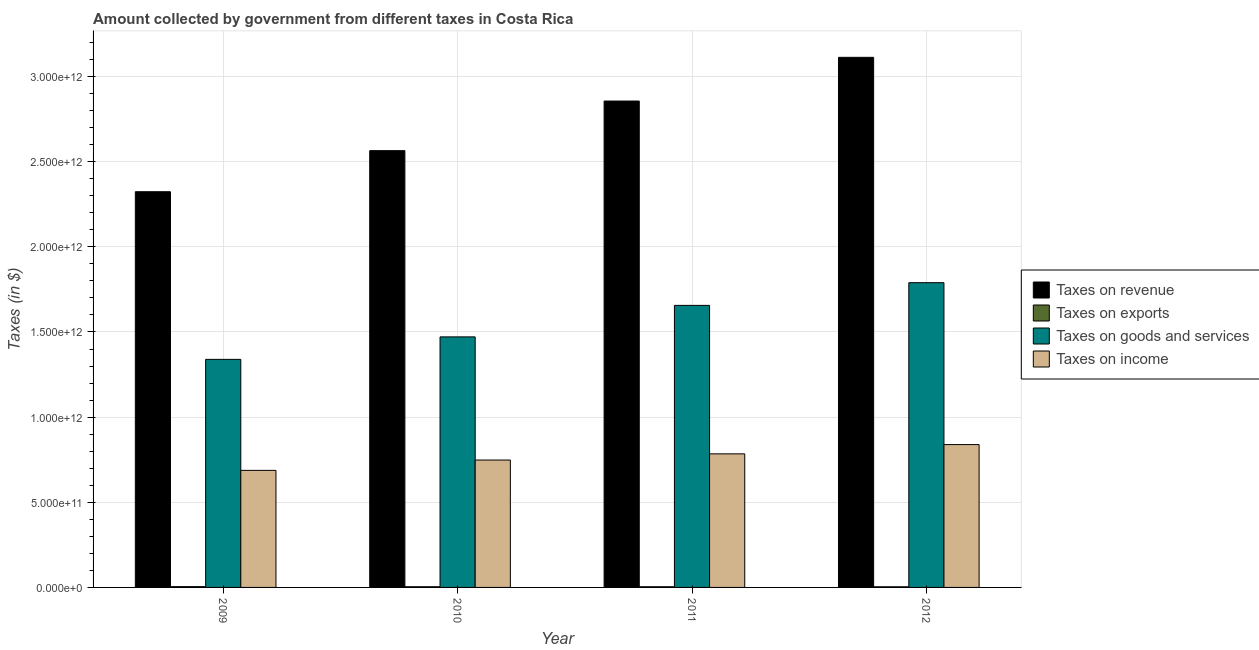What is the amount collected as tax on exports in 2010?
Make the answer very short. 3.97e+09. Across all years, what is the maximum amount collected as tax on exports?
Your response must be concise. 4.68e+09. Across all years, what is the minimum amount collected as tax on exports?
Your answer should be compact. 3.82e+09. In which year was the amount collected as tax on goods maximum?
Your answer should be compact. 2012. In which year was the amount collected as tax on exports minimum?
Offer a very short reply. 2012. What is the total amount collected as tax on exports in the graph?
Offer a terse response. 1.65e+1. What is the difference between the amount collected as tax on income in 2010 and that in 2011?
Give a very brief answer. -3.63e+1. What is the difference between the amount collected as tax on revenue in 2009 and the amount collected as tax on goods in 2011?
Give a very brief answer. -5.33e+11. What is the average amount collected as tax on goods per year?
Your answer should be compact. 1.56e+12. What is the ratio of the amount collected as tax on revenue in 2009 to that in 2011?
Keep it short and to the point. 0.81. Is the amount collected as tax on revenue in 2009 less than that in 2011?
Provide a short and direct response. Yes. What is the difference between the highest and the second highest amount collected as tax on income?
Provide a short and direct response. 5.44e+1. What is the difference between the highest and the lowest amount collected as tax on revenue?
Make the answer very short. 7.89e+11. What does the 1st bar from the left in 2009 represents?
Offer a terse response. Taxes on revenue. What does the 4th bar from the right in 2011 represents?
Your answer should be very brief. Taxes on revenue. Is it the case that in every year, the sum of the amount collected as tax on revenue and amount collected as tax on exports is greater than the amount collected as tax on goods?
Offer a terse response. Yes. How many bars are there?
Offer a very short reply. 16. Are all the bars in the graph horizontal?
Your answer should be very brief. No. What is the difference between two consecutive major ticks on the Y-axis?
Your answer should be compact. 5.00e+11. Are the values on the major ticks of Y-axis written in scientific E-notation?
Provide a short and direct response. Yes. Does the graph contain any zero values?
Offer a very short reply. No. Does the graph contain grids?
Offer a very short reply. Yes. Where does the legend appear in the graph?
Make the answer very short. Center right. How are the legend labels stacked?
Your answer should be very brief. Vertical. What is the title of the graph?
Your answer should be compact. Amount collected by government from different taxes in Costa Rica. Does "UNDP" appear as one of the legend labels in the graph?
Offer a terse response. No. What is the label or title of the Y-axis?
Make the answer very short. Taxes (in $). What is the Taxes (in $) of Taxes on revenue in 2009?
Give a very brief answer. 2.32e+12. What is the Taxes (in $) in Taxes on exports in 2009?
Make the answer very short. 4.68e+09. What is the Taxes (in $) in Taxes on goods and services in 2009?
Your answer should be compact. 1.34e+12. What is the Taxes (in $) in Taxes on income in 2009?
Offer a terse response. 6.87e+11. What is the Taxes (in $) of Taxes on revenue in 2010?
Provide a succinct answer. 2.56e+12. What is the Taxes (in $) in Taxes on exports in 2010?
Ensure brevity in your answer.  3.97e+09. What is the Taxes (in $) of Taxes on goods and services in 2010?
Your response must be concise. 1.47e+12. What is the Taxes (in $) in Taxes on income in 2010?
Make the answer very short. 7.48e+11. What is the Taxes (in $) in Taxes on revenue in 2011?
Make the answer very short. 2.86e+12. What is the Taxes (in $) in Taxes on exports in 2011?
Ensure brevity in your answer.  3.99e+09. What is the Taxes (in $) of Taxes on goods and services in 2011?
Ensure brevity in your answer.  1.66e+12. What is the Taxes (in $) of Taxes on income in 2011?
Provide a succinct answer. 7.84e+11. What is the Taxes (in $) in Taxes on revenue in 2012?
Your answer should be compact. 3.11e+12. What is the Taxes (in $) of Taxes on exports in 2012?
Provide a succinct answer. 3.82e+09. What is the Taxes (in $) in Taxes on goods and services in 2012?
Your answer should be compact. 1.79e+12. What is the Taxes (in $) in Taxes on income in 2012?
Offer a terse response. 8.39e+11. Across all years, what is the maximum Taxes (in $) in Taxes on revenue?
Ensure brevity in your answer.  3.11e+12. Across all years, what is the maximum Taxes (in $) in Taxes on exports?
Ensure brevity in your answer.  4.68e+09. Across all years, what is the maximum Taxes (in $) in Taxes on goods and services?
Make the answer very short. 1.79e+12. Across all years, what is the maximum Taxes (in $) in Taxes on income?
Provide a short and direct response. 8.39e+11. Across all years, what is the minimum Taxes (in $) in Taxes on revenue?
Give a very brief answer. 2.32e+12. Across all years, what is the minimum Taxes (in $) in Taxes on exports?
Offer a terse response. 3.82e+09. Across all years, what is the minimum Taxes (in $) in Taxes on goods and services?
Provide a short and direct response. 1.34e+12. Across all years, what is the minimum Taxes (in $) in Taxes on income?
Your answer should be very brief. 6.87e+11. What is the total Taxes (in $) in Taxes on revenue in the graph?
Keep it short and to the point. 1.09e+13. What is the total Taxes (in $) in Taxes on exports in the graph?
Your answer should be compact. 1.65e+1. What is the total Taxes (in $) of Taxes on goods and services in the graph?
Ensure brevity in your answer.  6.26e+12. What is the total Taxes (in $) in Taxes on income in the graph?
Give a very brief answer. 3.06e+12. What is the difference between the Taxes (in $) in Taxes on revenue in 2009 and that in 2010?
Your response must be concise. -2.41e+11. What is the difference between the Taxes (in $) in Taxes on exports in 2009 and that in 2010?
Offer a terse response. 7.04e+08. What is the difference between the Taxes (in $) in Taxes on goods and services in 2009 and that in 2010?
Your answer should be very brief. -1.32e+11. What is the difference between the Taxes (in $) in Taxes on income in 2009 and that in 2010?
Make the answer very short. -6.07e+1. What is the difference between the Taxes (in $) in Taxes on revenue in 2009 and that in 2011?
Make the answer very short. -5.33e+11. What is the difference between the Taxes (in $) in Taxes on exports in 2009 and that in 2011?
Make the answer very short. 6.87e+08. What is the difference between the Taxes (in $) in Taxes on goods and services in 2009 and that in 2011?
Provide a succinct answer. -3.17e+11. What is the difference between the Taxes (in $) of Taxes on income in 2009 and that in 2011?
Offer a very short reply. -9.70e+1. What is the difference between the Taxes (in $) in Taxes on revenue in 2009 and that in 2012?
Your answer should be compact. -7.89e+11. What is the difference between the Taxes (in $) of Taxes on exports in 2009 and that in 2012?
Give a very brief answer. 8.54e+08. What is the difference between the Taxes (in $) in Taxes on goods and services in 2009 and that in 2012?
Make the answer very short. -4.50e+11. What is the difference between the Taxes (in $) of Taxes on income in 2009 and that in 2012?
Make the answer very short. -1.51e+11. What is the difference between the Taxes (in $) of Taxes on revenue in 2010 and that in 2011?
Provide a short and direct response. -2.91e+11. What is the difference between the Taxes (in $) of Taxes on exports in 2010 and that in 2011?
Your answer should be very brief. -1.76e+07. What is the difference between the Taxes (in $) in Taxes on goods and services in 2010 and that in 2011?
Ensure brevity in your answer.  -1.85e+11. What is the difference between the Taxes (in $) in Taxes on income in 2010 and that in 2011?
Your answer should be compact. -3.63e+1. What is the difference between the Taxes (in $) in Taxes on revenue in 2010 and that in 2012?
Keep it short and to the point. -5.48e+11. What is the difference between the Taxes (in $) of Taxes on exports in 2010 and that in 2012?
Your answer should be very brief. 1.49e+08. What is the difference between the Taxes (in $) in Taxes on goods and services in 2010 and that in 2012?
Keep it short and to the point. -3.18e+11. What is the difference between the Taxes (in $) in Taxes on income in 2010 and that in 2012?
Your answer should be compact. -9.07e+1. What is the difference between the Taxes (in $) in Taxes on revenue in 2011 and that in 2012?
Keep it short and to the point. -2.57e+11. What is the difference between the Taxes (in $) of Taxes on exports in 2011 and that in 2012?
Your answer should be very brief. 1.67e+08. What is the difference between the Taxes (in $) in Taxes on goods and services in 2011 and that in 2012?
Provide a succinct answer. -1.33e+11. What is the difference between the Taxes (in $) in Taxes on income in 2011 and that in 2012?
Give a very brief answer. -5.44e+1. What is the difference between the Taxes (in $) of Taxes on revenue in 2009 and the Taxes (in $) of Taxes on exports in 2010?
Keep it short and to the point. 2.32e+12. What is the difference between the Taxes (in $) of Taxes on revenue in 2009 and the Taxes (in $) of Taxes on goods and services in 2010?
Give a very brief answer. 8.52e+11. What is the difference between the Taxes (in $) in Taxes on revenue in 2009 and the Taxes (in $) in Taxes on income in 2010?
Keep it short and to the point. 1.58e+12. What is the difference between the Taxes (in $) of Taxes on exports in 2009 and the Taxes (in $) of Taxes on goods and services in 2010?
Your response must be concise. -1.47e+12. What is the difference between the Taxes (in $) of Taxes on exports in 2009 and the Taxes (in $) of Taxes on income in 2010?
Keep it short and to the point. -7.43e+11. What is the difference between the Taxes (in $) in Taxes on goods and services in 2009 and the Taxes (in $) in Taxes on income in 2010?
Provide a short and direct response. 5.91e+11. What is the difference between the Taxes (in $) in Taxes on revenue in 2009 and the Taxes (in $) in Taxes on exports in 2011?
Offer a terse response. 2.32e+12. What is the difference between the Taxes (in $) of Taxes on revenue in 2009 and the Taxes (in $) of Taxes on goods and services in 2011?
Offer a very short reply. 6.67e+11. What is the difference between the Taxes (in $) of Taxes on revenue in 2009 and the Taxes (in $) of Taxes on income in 2011?
Offer a very short reply. 1.54e+12. What is the difference between the Taxes (in $) of Taxes on exports in 2009 and the Taxes (in $) of Taxes on goods and services in 2011?
Provide a succinct answer. -1.65e+12. What is the difference between the Taxes (in $) of Taxes on exports in 2009 and the Taxes (in $) of Taxes on income in 2011?
Ensure brevity in your answer.  -7.80e+11. What is the difference between the Taxes (in $) in Taxes on goods and services in 2009 and the Taxes (in $) in Taxes on income in 2011?
Your response must be concise. 5.55e+11. What is the difference between the Taxes (in $) of Taxes on revenue in 2009 and the Taxes (in $) of Taxes on exports in 2012?
Your response must be concise. 2.32e+12. What is the difference between the Taxes (in $) in Taxes on revenue in 2009 and the Taxes (in $) in Taxes on goods and services in 2012?
Offer a terse response. 5.34e+11. What is the difference between the Taxes (in $) in Taxes on revenue in 2009 and the Taxes (in $) in Taxes on income in 2012?
Provide a short and direct response. 1.48e+12. What is the difference between the Taxes (in $) in Taxes on exports in 2009 and the Taxes (in $) in Taxes on goods and services in 2012?
Your answer should be very brief. -1.78e+12. What is the difference between the Taxes (in $) in Taxes on exports in 2009 and the Taxes (in $) in Taxes on income in 2012?
Keep it short and to the point. -8.34e+11. What is the difference between the Taxes (in $) in Taxes on goods and services in 2009 and the Taxes (in $) in Taxes on income in 2012?
Give a very brief answer. 5.00e+11. What is the difference between the Taxes (in $) in Taxes on revenue in 2010 and the Taxes (in $) in Taxes on exports in 2011?
Provide a succinct answer. 2.56e+12. What is the difference between the Taxes (in $) of Taxes on revenue in 2010 and the Taxes (in $) of Taxes on goods and services in 2011?
Ensure brevity in your answer.  9.09e+11. What is the difference between the Taxes (in $) in Taxes on revenue in 2010 and the Taxes (in $) in Taxes on income in 2011?
Give a very brief answer. 1.78e+12. What is the difference between the Taxes (in $) of Taxes on exports in 2010 and the Taxes (in $) of Taxes on goods and services in 2011?
Your answer should be very brief. -1.65e+12. What is the difference between the Taxes (in $) of Taxes on exports in 2010 and the Taxes (in $) of Taxes on income in 2011?
Offer a terse response. -7.80e+11. What is the difference between the Taxes (in $) of Taxes on goods and services in 2010 and the Taxes (in $) of Taxes on income in 2011?
Offer a very short reply. 6.87e+11. What is the difference between the Taxes (in $) in Taxes on revenue in 2010 and the Taxes (in $) in Taxes on exports in 2012?
Offer a terse response. 2.56e+12. What is the difference between the Taxes (in $) in Taxes on revenue in 2010 and the Taxes (in $) in Taxes on goods and services in 2012?
Offer a very short reply. 7.75e+11. What is the difference between the Taxes (in $) in Taxes on revenue in 2010 and the Taxes (in $) in Taxes on income in 2012?
Offer a very short reply. 1.73e+12. What is the difference between the Taxes (in $) in Taxes on exports in 2010 and the Taxes (in $) in Taxes on goods and services in 2012?
Give a very brief answer. -1.79e+12. What is the difference between the Taxes (in $) of Taxes on exports in 2010 and the Taxes (in $) of Taxes on income in 2012?
Your answer should be compact. -8.35e+11. What is the difference between the Taxes (in $) of Taxes on goods and services in 2010 and the Taxes (in $) of Taxes on income in 2012?
Your response must be concise. 6.32e+11. What is the difference between the Taxes (in $) of Taxes on revenue in 2011 and the Taxes (in $) of Taxes on exports in 2012?
Make the answer very short. 2.85e+12. What is the difference between the Taxes (in $) of Taxes on revenue in 2011 and the Taxes (in $) of Taxes on goods and services in 2012?
Keep it short and to the point. 1.07e+12. What is the difference between the Taxes (in $) in Taxes on revenue in 2011 and the Taxes (in $) in Taxes on income in 2012?
Offer a very short reply. 2.02e+12. What is the difference between the Taxes (in $) in Taxes on exports in 2011 and the Taxes (in $) in Taxes on goods and services in 2012?
Provide a succinct answer. -1.79e+12. What is the difference between the Taxes (in $) of Taxes on exports in 2011 and the Taxes (in $) of Taxes on income in 2012?
Make the answer very short. -8.35e+11. What is the difference between the Taxes (in $) in Taxes on goods and services in 2011 and the Taxes (in $) in Taxes on income in 2012?
Give a very brief answer. 8.17e+11. What is the average Taxes (in $) in Taxes on revenue per year?
Your response must be concise. 2.71e+12. What is the average Taxes (in $) of Taxes on exports per year?
Provide a short and direct response. 4.12e+09. What is the average Taxes (in $) in Taxes on goods and services per year?
Provide a succinct answer. 1.56e+12. What is the average Taxes (in $) of Taxes on income per year?
Offer a very short reply. 7.65e+11. In the year 2009, what is the difference between the Taxes (in $) in Taxes on revenue and Taxes (in $) in Taxes on exports?
Keep it short and to the point. 2.32e+12. In the year 2009, what is the difference between the Taxes (in $) in Taxes on revenue and Taxes (in $) in Taxes on goods and services?
Give a very brief answer. 9.84e+11. In the year 2009, what is the difference between the Taxes (in $) in Taxes on revenue and Taxes (in $) in Taxes on income?
Provide a short and direct response. 1.64e+12. In the year 2009, what is the difference between the Taxes (in $) of Taxes on exports and Taxes (in $) of Taxes on goods and services?
Offer a very short reply. -1.33e+12. In the year 2009, what is the difference between the Taxes (in $) in Taxes on exports and Taxes (in $) in Taxes on income?
Your response must be concise. -6.83e+11. In the year 2009, what is the difference between the Taxes (in $) in Taxes on goods and services and Taxes (in $) in Taxes on income?
Your response must be concise. 6.52e+11. In the year 2010, what is the difference between the Taxes (in $) in Taxes on revenue and Taxes (in $) in Taxes on exports?
Ensure brevity in your answer.  2.56e+12. In the year 2010, what is the difference between the Taxes (in $) of Taxes on revenue and Taxes (in $) of Taxes on goods and services?
Offer a terse response. 1.09e+12. In the year 2010, what is the difference between the Taxes (in $) in Taxes on revenue and Taxes (in $) in Taxes on income?
Offer a terse response. 1.82e+12. In the year 2010, what is the difference between the Taxes (in $) of Taxes on exports and Taxes (in $) of Taxes on goods and services?
Provide a succinct answer. -1.47e+12. In the year 2010, what is the difference between the Taxes (in $) of Taxes on exports and Taxes (in $) of Taxes on income?
Offer a terse response. -7.44e+11. In the year 2010, what is the difference between the Taxes (in $) of Taxes on goods and services and Taxes (in $) of Taxes on income?
Your answer should be very brief. 7.23e+11. In the year 2011, what is the difference between the Taxes (in $) in Taxes on revenue and Taxes (in $) in Taxes on exports?
Provide a succinct answer. 2.85e+12. In the year 2011, what is the difference between the Taxes (in $) in Taxes on revenue and Taxes (in $) in Taxes on goods and services?
Keep it short and to the point. 1.20e+12. In the year 2011, what is the difference between the Taxes (in $) of Taxes on revenue and Taxes (in $) of Taxes on income?
Your answer should be very brief. 2.07e+12. In the year 2011, what is the difference between the Taxes (in $) of Taxes on exports and Taxes (in $) of Taxes on goods and services?
Your answer should be very brief. -1.65e+12. In the year 2011, what is the difference between the Taxes (in $) of Taxes on exports and Taxes (in $) of Taxes on income?
Offer a very short reply. -7.80e+11. In the year 2011, what is the difference between the Taxes (in $) of Taxes on goods and services and Taxes (in $) of Taxes on income?
Offer a terse response. 8.72e+11. In the year 2012, what is the difference between the Taxes (in $) of Taxes on revenue and Taxes (in $) of Taxes on exports?
Provide a succinct answer. 3.11e+12. In the year 2012, what is the difference between the Taxes (in $) of Taxes on revenue and Taxes (in $) of Taxes on goods and services?
Ensure brevity in your answer.  1.32e+12. In the year 2012, what is the difference between the Taxes (in $) in Taxes on revenue and Taxes (in $) in Taxes on income?
Offer a very short reply. 2.27e+12. In the year 2012, what is the difference between the Taxes (in $) of Taxes on exports and Taxes (in $) of Taxes on goods and services?
Give a very brief answer. -1.79e+12. In the year 2012, what is the difference between the Taxes (in $) of Taxes on exports and Taxes (in $) of Taxes on income?
Provide a short and direct response. -8.35e+11. In the year 2012, what is the difference between the Taxes (in $) of Taxes on goods and services and Taxes (in $) of Taxes on income?
Ensure brevity in your answer.  9.51e+11. What is the ratio of the Taxes (in $) of Taxes on revenue in 2009 to that in 2010?
Your response must be concise. 0.91. What is the ratio of the Taxes (in $) in Taxes on exports in 2009 to that in 2010?
Your answer should be very brief. 1.18. What is the ratio of the Taxes (in $) of Taxes on goods and services in 2009 to that in 2010?
Provide a short and direct response. 0.91. What is the ratio of the Taxes (in $) in Taxes on income in 2009 to that in 2010?
Make the answer very short. 0.92. What is the ratio of the Taxes (in $) of Taxes on revenue in 2009 to that in 2011?
Keep it short and to the point. 0.81. What is the ratio of the Taxes (in $) in Taxes on exports in 2009 to that in 2011?
Give a very brief answer. 1.17. What is the ratio of the Taxes (in $) in Taxes on goods and services in 2009 to that in 2011?
Keep it short and to the point. 0.81. What is the ratio of the Taxes (in $) in Taxes on income in 2009 to that in 2011?
Give a very brief answer. 0.88. What is the ratio of the Taxes (in $) of Taxes on revenue in 2009 to that in 2012?
Make the answer very short. 0.75. What is the ratio of the Taxes (in $) in Taxes on exports in 2009 to that in 2012?
Provide a short and direct response. 1.22. What is the ratio of the Taxes (in $) of Taxes on goods and services in 2009 to that in 2012?
Provide a succinct answer. 0.75. What is the ratio of the Taxes (in $) in Taxes on income in 2009 to that in 2012?
Offer a very short reply. 0.82. What is the ratio of the Taxes (in $) in Taxes on revenue in 2010 to that in 2011?
Ensure brevity in your answer.  0.9. What is the ratio of the Taxes (in $) of Taxes on exports in 2010 to that in 2011?
Your answer should be very brief. 1. What is the ratio of the Taxes (in $) of Taxes on goods and services in 2010 to that in 2011?
Your answer should be compact. 0.89. What is the ratio of the Taxes (in $) in Taxes on income in 2010 to that in 2011?
Give a very brief answer. 0.95. What is the ratio of the Taxes (in $) in Taxes on revenue in 2010 to that in 2012?
Your answer should be very brief. 0.82. What is the ratio of the Taxes (in $) in Taxes on exports in 2010 to that in 2012?
Offer a very short reply. 1.04. What is the ratio of the Taxes (in $) in Taxes on goods and services in 2010 to that in 2012?
Offer a very short reply. 0.82. What is the ratio of the Taxes (in $) of Taxes on income in 2010 to that in 2012?
Give a very brief answer. 0.89. What is the ratio of the Taxes (in $) in Taxes on revenue in 2011 to that in 2012?
Provide a short and direct response. 0.92. What is the ratio of the Taxes (in $) of Taxes on exports in 2011 to that in 2012?
Give a very brief answer. 1.04. What is the ratio of the Taxes (in $) in Taxes on goods and services in 2011 to that in 2012?
Offer a very short reply. 0.93. What is the ratio of the Taxes (in $) of Taxes on income in 2011 to that in 2012?
Your answer should be compact. 0.94. What is the difference between the highest and the second highest Taxes (in $) in Taxes on revenue?
Make the answer very short. 2.57e+11. What is the difference between the highest and the second highest Taxes (in $) of Taxes on exports?
Give a very brief answer. 6.87e+08. What is the difference between the highest and the second highest Taxes (in $) in Taxes on goods and services?
Your response must be concise. 1.33e+11. What is the difference between the highest and the second highest Taxes (in $) of Taxes on income?
Ensure brevity in your answer.  5.44e+1. What is the difference between the highest and the lowest Taxes (in $) in Taxes on revenue?
Make the answer very short. 7.89e+11. What is the difference between the highest and the lowest Taxes (in $) in Taxes on exports?
Make the answer very short. 8.54e+08. What is the difference between the highest and the lowest Taxes (in $) of Taxes on goods and services?
Offer a very short reply. 4.50e+11. What is the difference between the highest and the lowest Taxes (in $) in Taxes on income?
Offer a very short reply. 1.51e+11. 